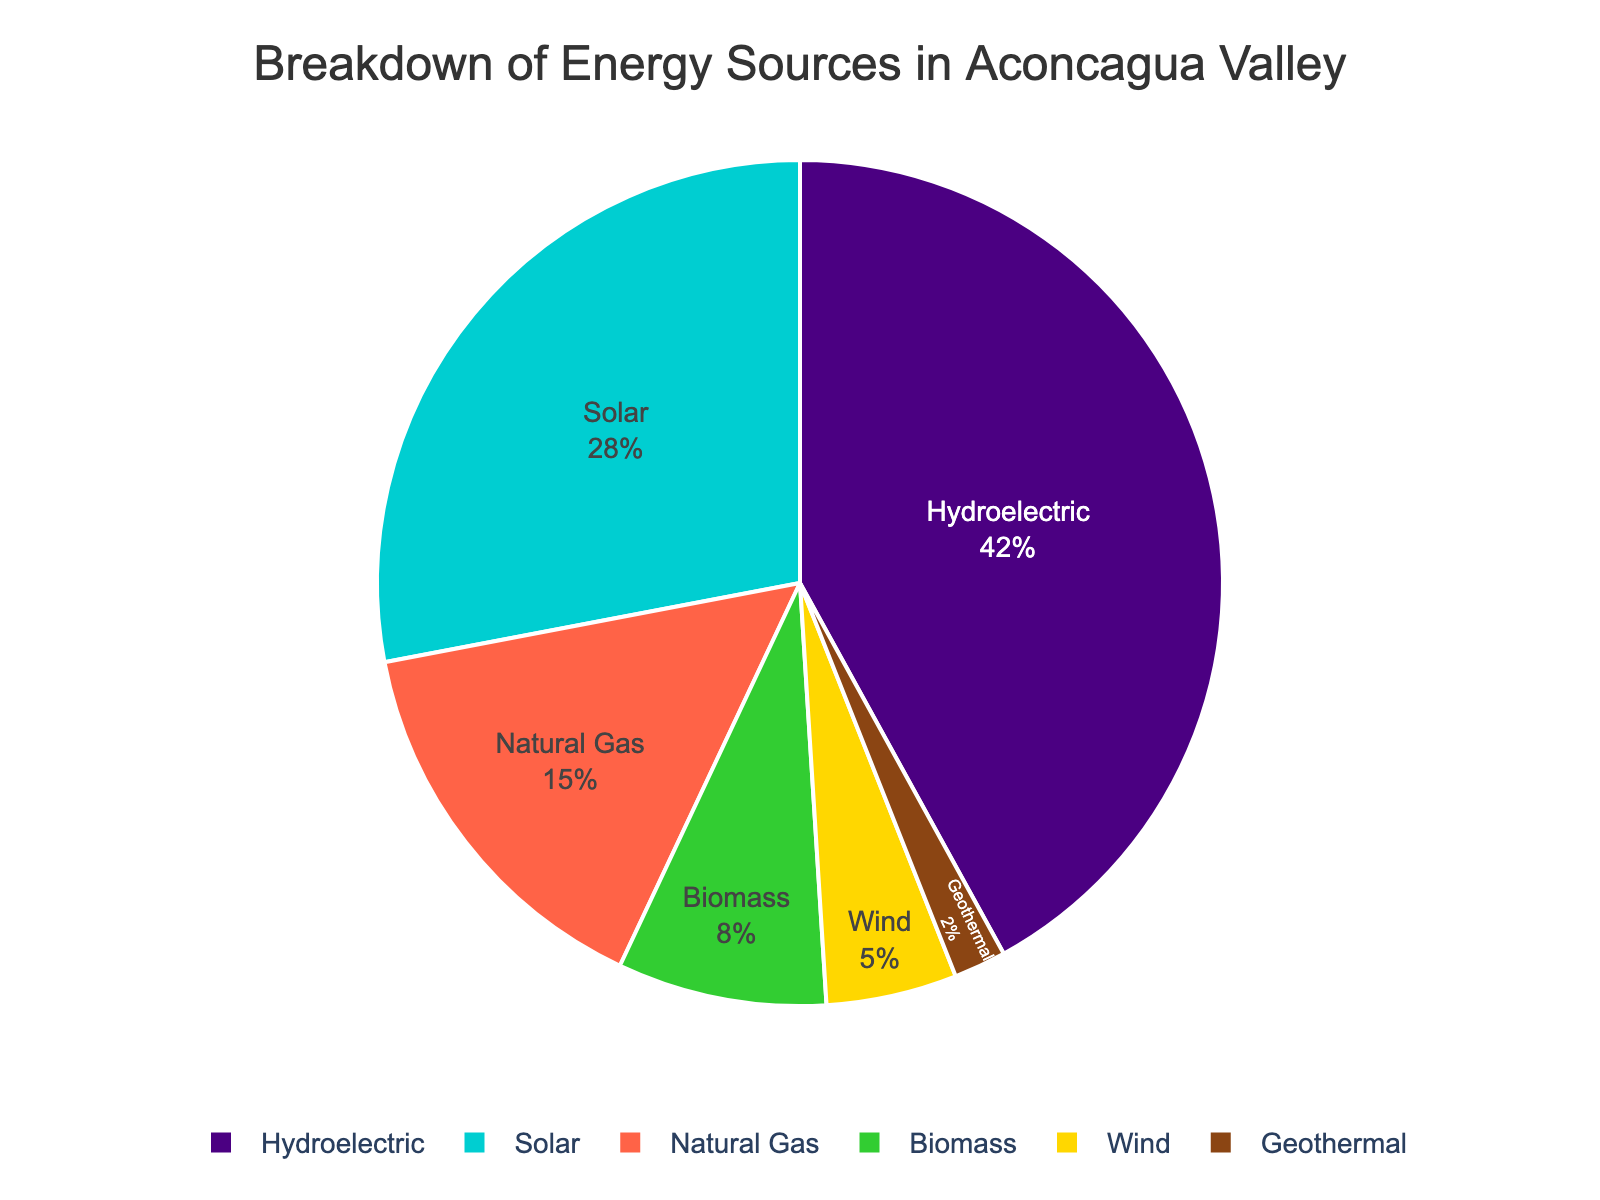what energy source is used the most in the Aconcagua Valley? The pie chart shows that Hydroelectric has the largest segment, which indicates that it is the most used energy source.
Answer: Hydroelectric What percentage of energy comes from renewable sources? Renewable energy sources in the chart are Hydroelectric, Solar, Biomass, Wind, and Geothermal. Their percentages are 42, 28, 8, 5, and 2 respectively. Summing these gives 42 + 28 + 8 + 5 + 2 = 85.
Answer: 85% Which energy source contributes less than 10%? Observing the pie chart, the sources that contribute less than 10% are Biomass, Wind, and Geothermal with percentages of 8, 5, and 2 respectively.
Answer: Biomass, Wind, and Geothermal What is the difference between the percentages of Solar and Natural Gas energy sources? From the pie chart, Solar contributes 28% and Natural Gas contributes 15%. The difference is 28 - 15 = 13.
Answer: 13% How does the usage of Wind energy compare with Biomass energy in terms of percentage? The chart shows that Wind energy contributes 5% while Biomass contributes 8%. Comparing these, Biomass energy has a higher percentage than Wind energy.
Answer: Biomass is higher What is the sum of the percentages of Solar, Wind, and Geothermal energy sources? According to the pie chart, Solar is 28%, Wind is 5%, and Geothermal is 2%. Summing these values: 28 + 5 + 2 = 35.
Answer: 35% Which energy source is visually represented by the color green in the pie chart? When viewing the pie chart, Biomass energy is represented by the green segment.
Answer: Biomass What percentage of energy comes from non-renewable sources? Non-renewable sources in the chart are Natural Gas. The percentage is directly 15% since it's the only non-renewable source listed.
Answer: 15% What is the combined contribution of Hydroelectric and Solar to the energy mix? Hydroelectric adds 42% and Solar adds 28%. Together, their combined contribution is 42 + 28 = 70.
Answer: 70% Which two energy sources combined make up exactly 30% of the energy usage? According to the pie chart, the sum of percentages for Natural Gas (15%) and Biomass (8%) and Wind (5%) equals 15 + 8 + 5 = 28. However, Solar (28%) combined with Wind (5%) and Geothermal (2%) equals 28 + 2 = 30. Hence, there are multiple possible combinations, but the simplest one is Natural Gas (15%) and Biomass (8%) and Wind (5%).
Answer: Natural Gas, Biomass, and Wind 